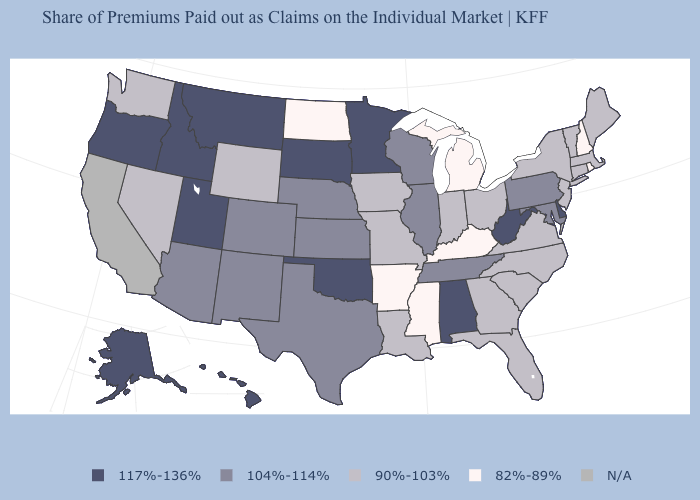What is the lowest value in the USA?
Give a very brief answer. 82%-89%. How many symbols are there in the legend?
Keep it brief. 5. Does the first symbol in the legend represent the smallest category?
Concise answer only. No. Which states have the lowest value in the USA?
Be succinct. Arkansas, Kentucky, Michigan, Mississippi, New Hampshire, North Dakota, Rhode Island. Name the states that have a value in the range N/A?
Be succinct. California. Does Mississippi have the lowest value in the USA?
Be succinct. Yes. Which states have the lowest value in the Northeast?
Be succinct. New Hampshire, Rhode Island. Which states have the lowest value in the USA?
Answer briefly. Arkansas, Kentucky, Michigan, Mississippi, New Hampshire, North Dakota, Rhode Island. Among the states that border Rhode Island , which have the lowest value?
Concise answer only. Connecticut, Massachusetts. How many symbols are there in the legend?
Quick response, please. 5. Name the states that have a value in the range 104%-114%?
Quick response, please. Arizona, Colorado, Illinois, Kansas, Maryland, Nebraska, New Mexico, Pennsylvania, Tennessee, Texas, Wisconsin. What is the highest value in the West ?
Concise answer only. 117%-136%. What is the highest value in the MidWest ?
Keep it brief. 117%-136%. Name the states that have a value in the range 82%-89%?
Keep it brief. Arkansas, Kentucky, Michigan, Mississippi, New Hampshire, North Dakota, Rhode Island. 